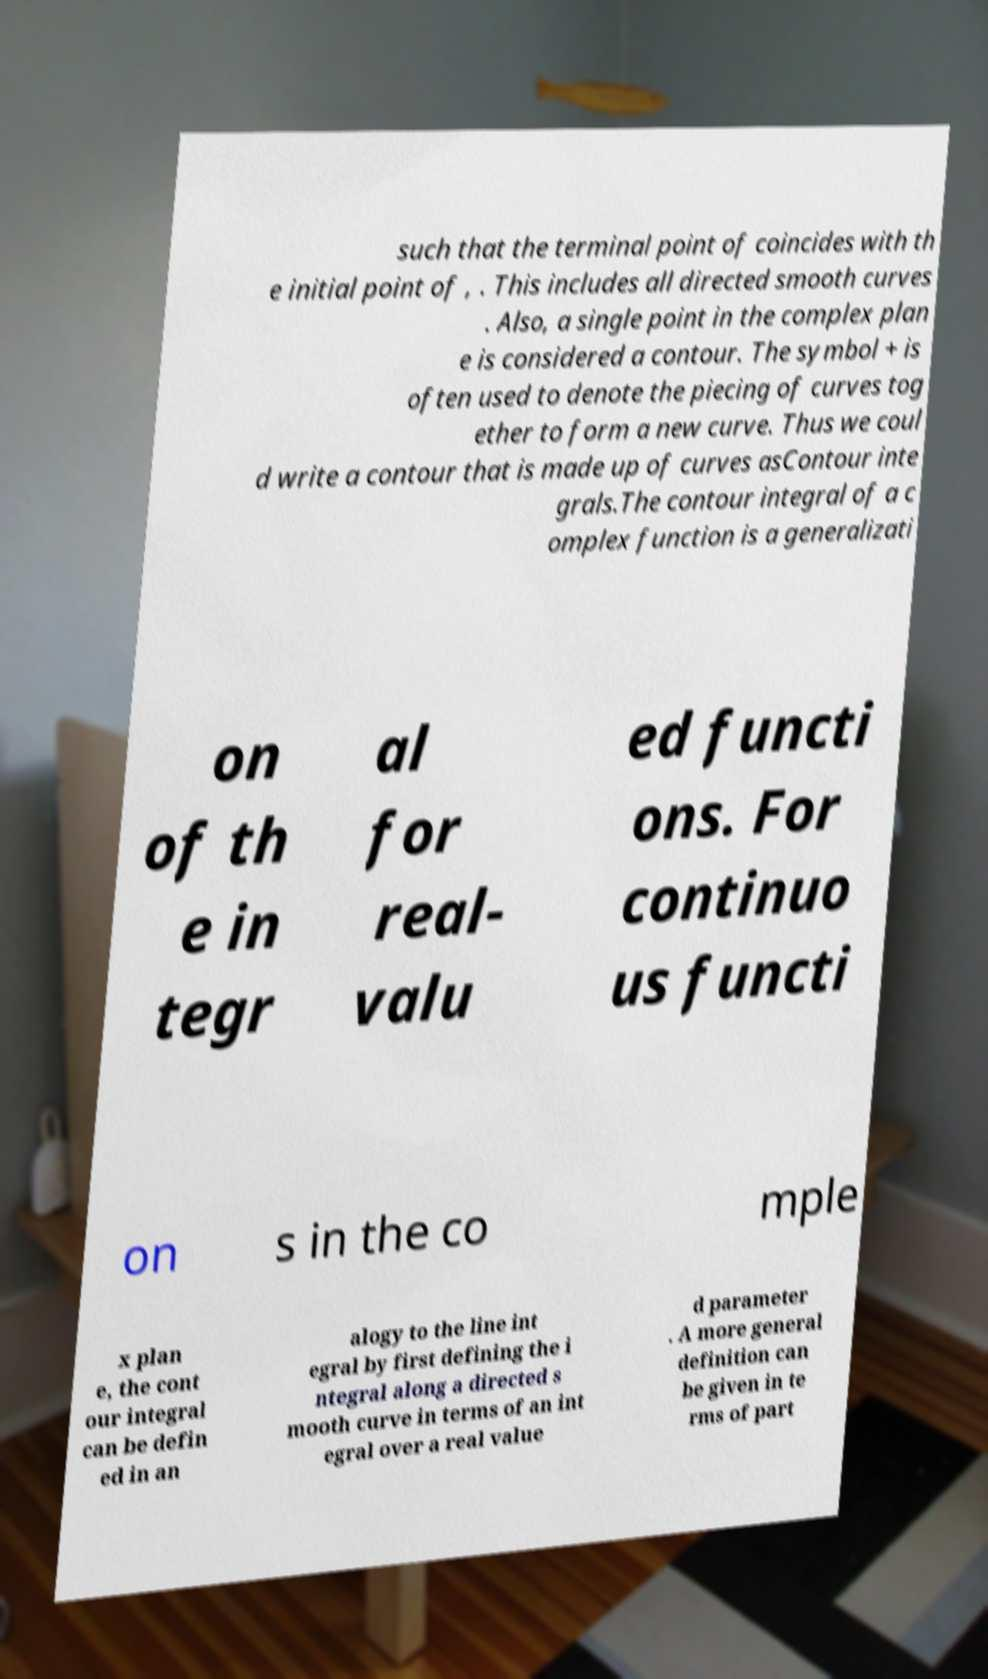For documentation purposes, I need the text within this image transcribed. Could you provide that? such that the terminal point of coincides with th e initial point of , . This includes all directed smooth curves . Also, a single point in the complex plan e is considered a contour. The symbol + is often used to denote the piecing of curves tog ether to form a new curve. Thus we coul d write a contour that is made up of curves asContour inte grals.The contour integral of a c omplex function is a generalizati on of th e in tegr al for real- valu ed functi ons. For continuo us functi on s in the co mple x plan e, the cont our integral can be defin ed in an alogy to the line int egral by first defining the i ntegral along a directed s mooth curve in terms of an int egral over a real value d parameter . A more general definition can be given in te rms of part 